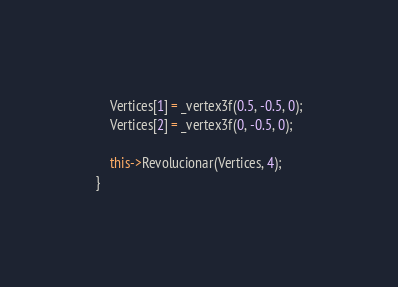<code> <loc_0><loc_0><loc_500><loc_500><_C++_>	Vertices[1] = _vertex3f(0.5, -0.5, 0);
	Vertices[2] = _vertex3f(0, -0.5, 0);

	this->Revolucionar(Vertices, 4);
}
</code> 